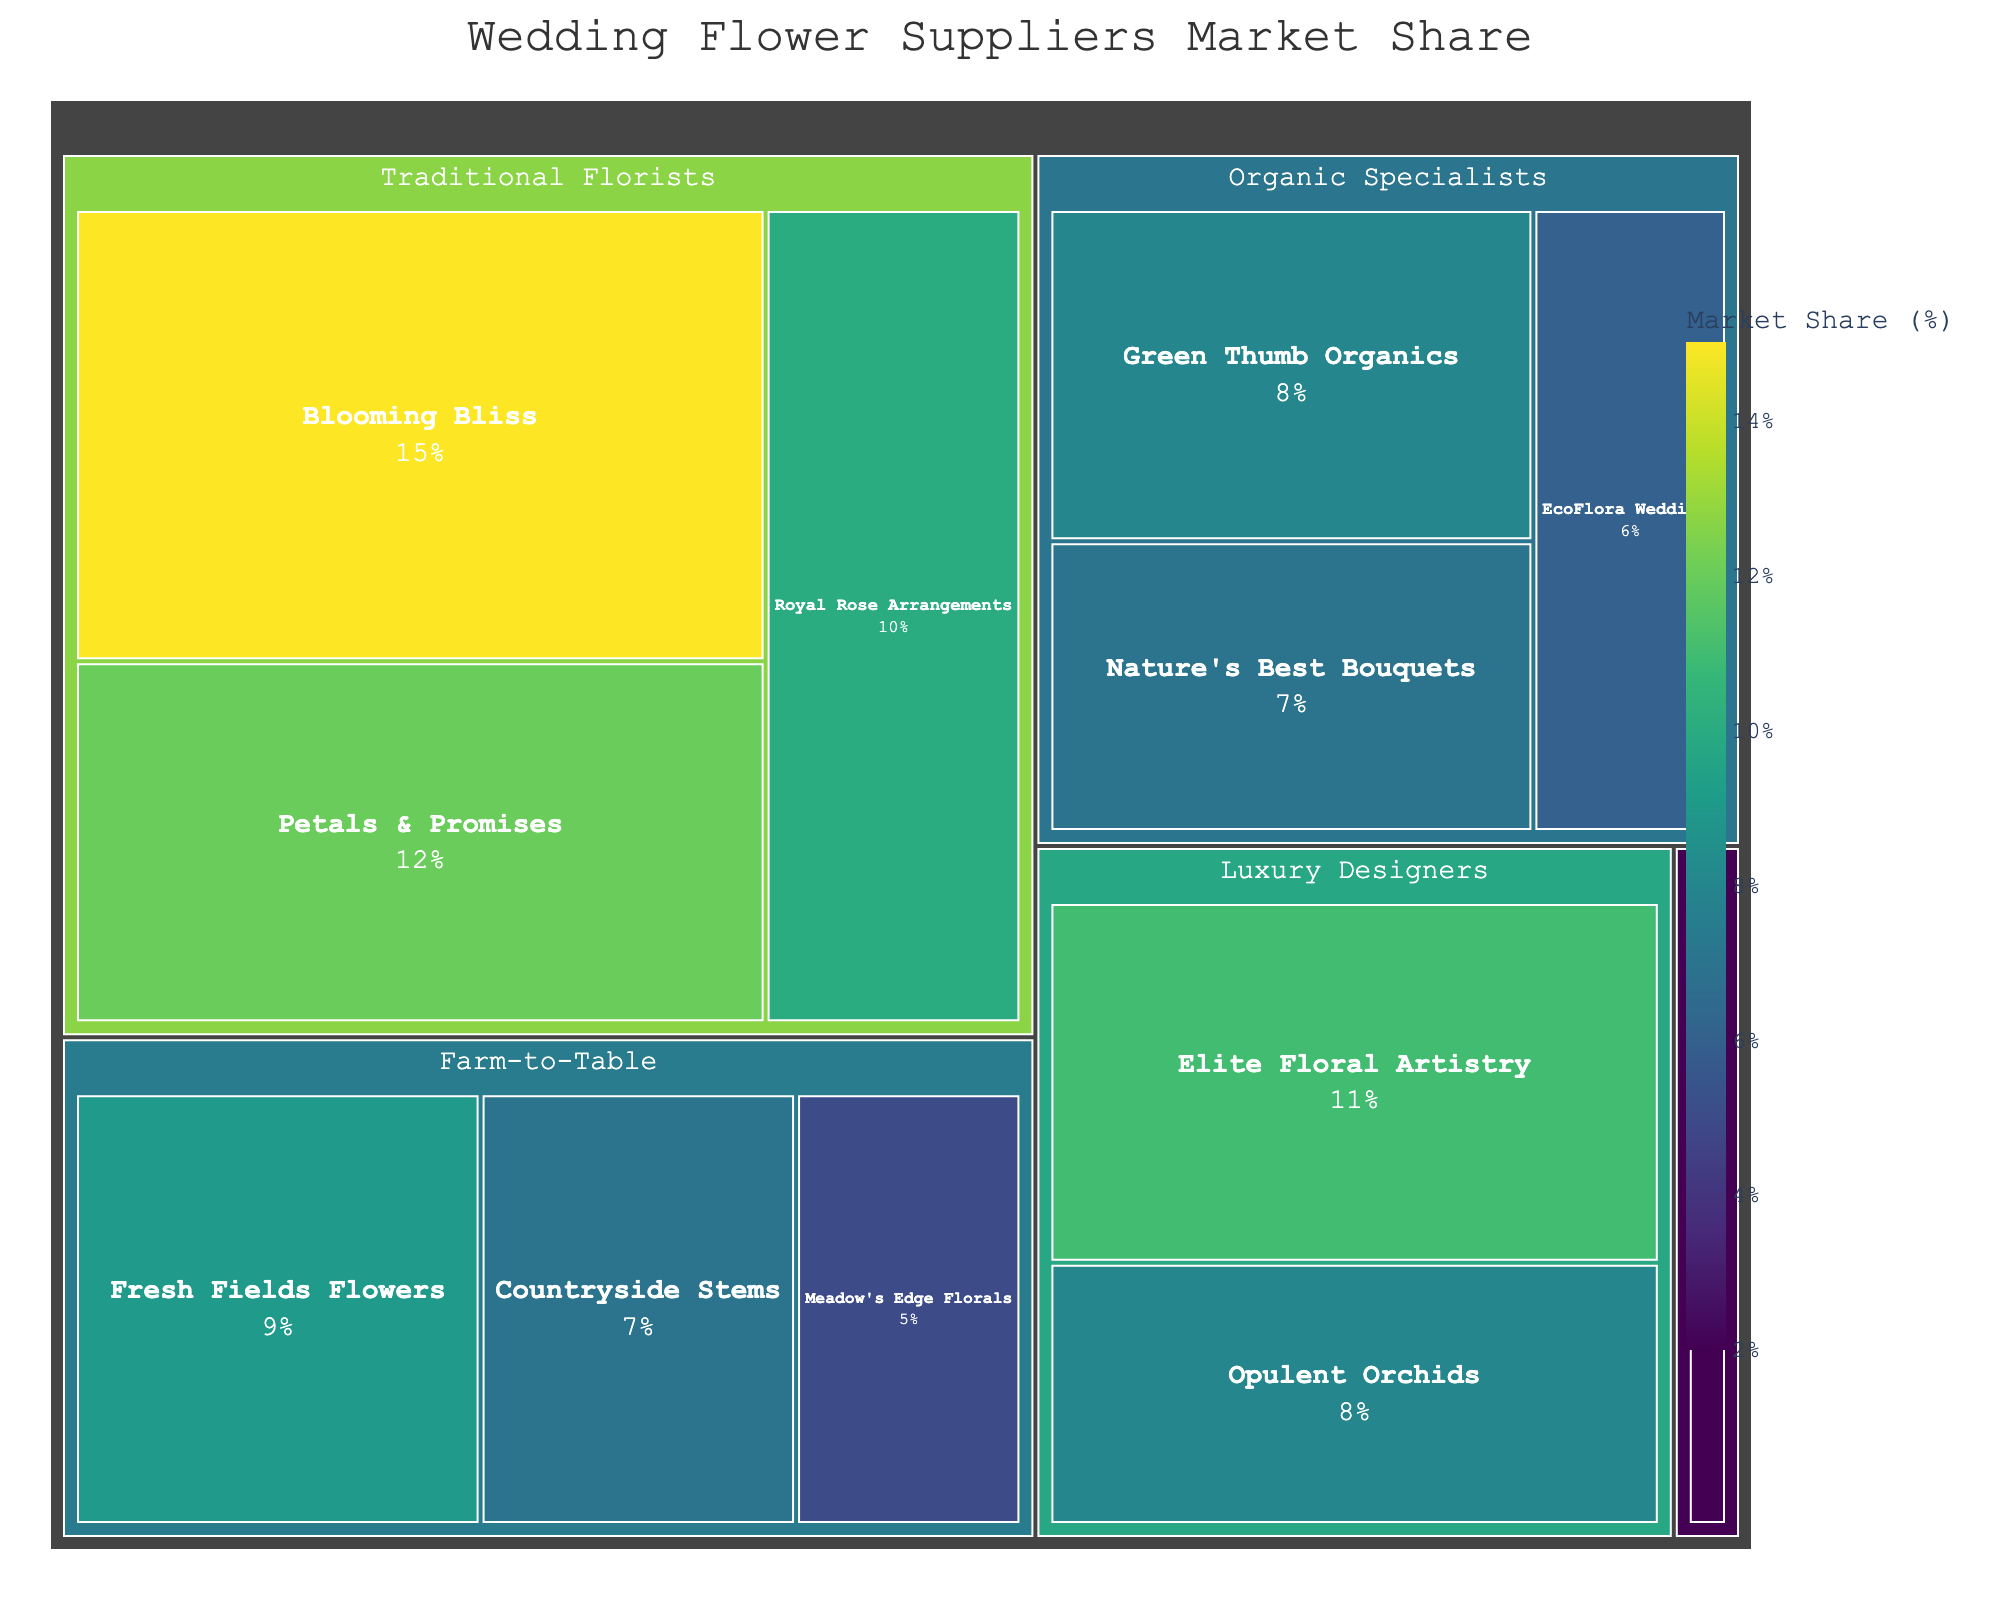What's the title of the figure? The title of the figure is displayed at the top of the plot in a larger font size, and it summarizes the content of the visualization.
Answer: Wedding Flower Suppliers Market Share Which supplier has the largest market share? To find the supplier with the largest market share, we look for the largest segment within the Treemap.
Answer: Blooming Bliss How does the market share of Green Thumb Organics compare to Petals & Promises? To compare the market share, look at the respective sizes of the segments representing each supplier. Green Thumb Organics has an 8% share, and Petals & Promises has a 12% share.
Answer: Green Thumb Organics has less market share What is the combined market share of all Traditional Florists? Add the market shares of all suppliers under the Traditional Florists category: 15% (Blooming Bliss) + 12% (Petals & Promises) + 10% (Royal Rose Arrangements).
Answer: 37% Which specialization category has the smallest total market share, and what is that share? Examine each category's combined market share. Budget-Friendly has only one supplier, Blossom Bargains, with a 2% market share.
Answer: Budget-Friendly at 2% What is the market share difference between Elite Floral Artistry and Fresh Fields Flowers? Elite Floral Artistry has an 11% share, and Fresh Fields Flowers has a 9% share. Subtract the smaller share from the larger one.
Answer: 2% How many suppliers fall under the Organic Specialists category? Count the number of segments under the Organic Specialists category. There are three suppliers: Green Thumb Organics, Nature's Best Bouquets, and EcoFlora Weddings.
Answer: 3 Which two suppliers have a combined market share equal to that of Blooming Bliss? Blooming Bliss has a 15% market share. Looking for a combination of two suppliers that sum up to 15%: Opulent Orchids (8%) + Countryside Stems (7%) equals 15%.
Answer: Opulent Orchids and Countryside Stems What percentage of the market is held by Farm-to-Table suppliers? Add the market shares of all Farm-to-Table suppliers: 9% (Fresh Fields Flowers) + 7% (Countryside Stems) + 5% (Meadow's Edge Florals).
Answer: 21% Which supplier within the Luxury Designers category has a higher market share? Compare the two suppliers in the Luxury Designers category: Elite Floral Artistry (11%) and Opulent Orchids (8%).
Answer: Elite Floral Artistry 